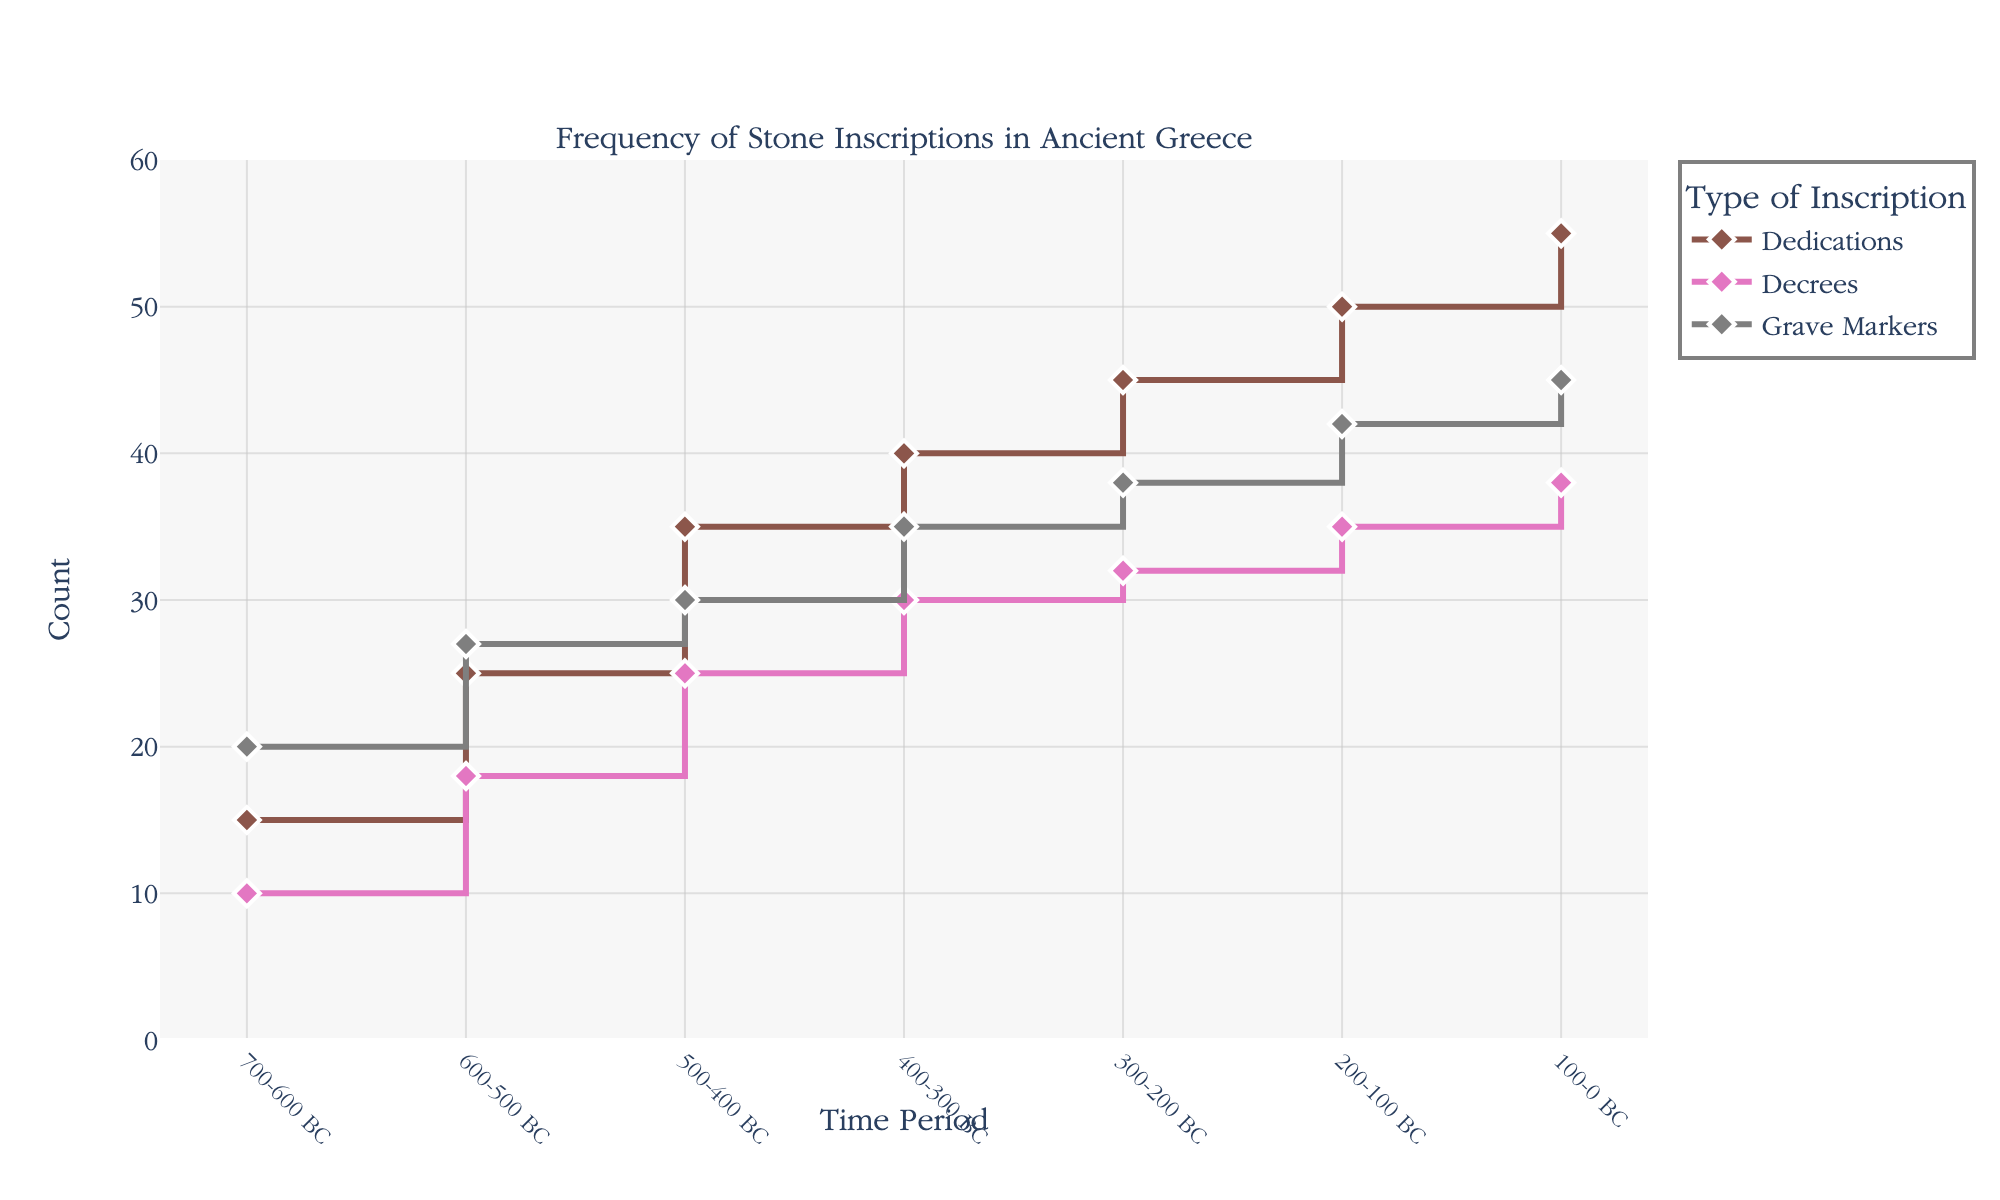What is the title of the figure? The title of the figure is located at the top of the plot. It provides a broad description of what the figure represents.
Answer: Frequency of Stone Inscriptions in Ancient Greece How many different types of stone inscriptions are shown in the figure? The types of stone inscriptions can be identified by looking at the legend on the right side of the plot, which lists each type with its corresponding color.
Answer: 3 Which type of inscription had the highest count in the period 100-0 BC? By observing the final points on the respective lines in the figure, we can compare the counts directly. The one with the highest point is the answer.
Answer: Dedications What is the visual color used for Grave Markers in the plot? The color corresponding to Grave Markers can be identified by checking the legend which associates each type with a specific color.
Answer: Gray What was the count difference between Decrees and Grave Markers in the period 200-100 BC? By looking at the specific data points for Decrees and Grave Markers in the period 200-100 BC, subtract Decrees' count from Grave Markers' count.
Answer: 7 (42 - 35) What is the trend of Dedications from 700-600 BC to 100-0 BC? Observing the points for Dedications from the earliest to the latest time period, note the overall direction and change.
Answer: Increasing How much more frequent were Grave Markers than Decrees in the period 500-400 BC? Compare the y-values (counts) of Grave Markers and Decrees for the period 500-400 BC, then calculate the difference.
Answer: 5 (30 - 25) Which time period had the least count for Decrees? By looking at the data points for Decrees across all time periods, identify the period with the lowest point on the y-axis.
Answer: 700-600 BC What is the combined count of all types of inscriptions for the period 300-200 BC? Sum the y-values (counts) of Dedications, Decrees, and Grave Markers for the period 300-200 BC.
Answer: 115 (45 + 32 + 38) During which period did all three types of inscriptions show an increasing trend as compared to the previous period? Compare the spatial positions of data points from one period to the next for all three types. Identify the period where each type's count is higher than in the preceding period.
Answer: 600-500 BC 